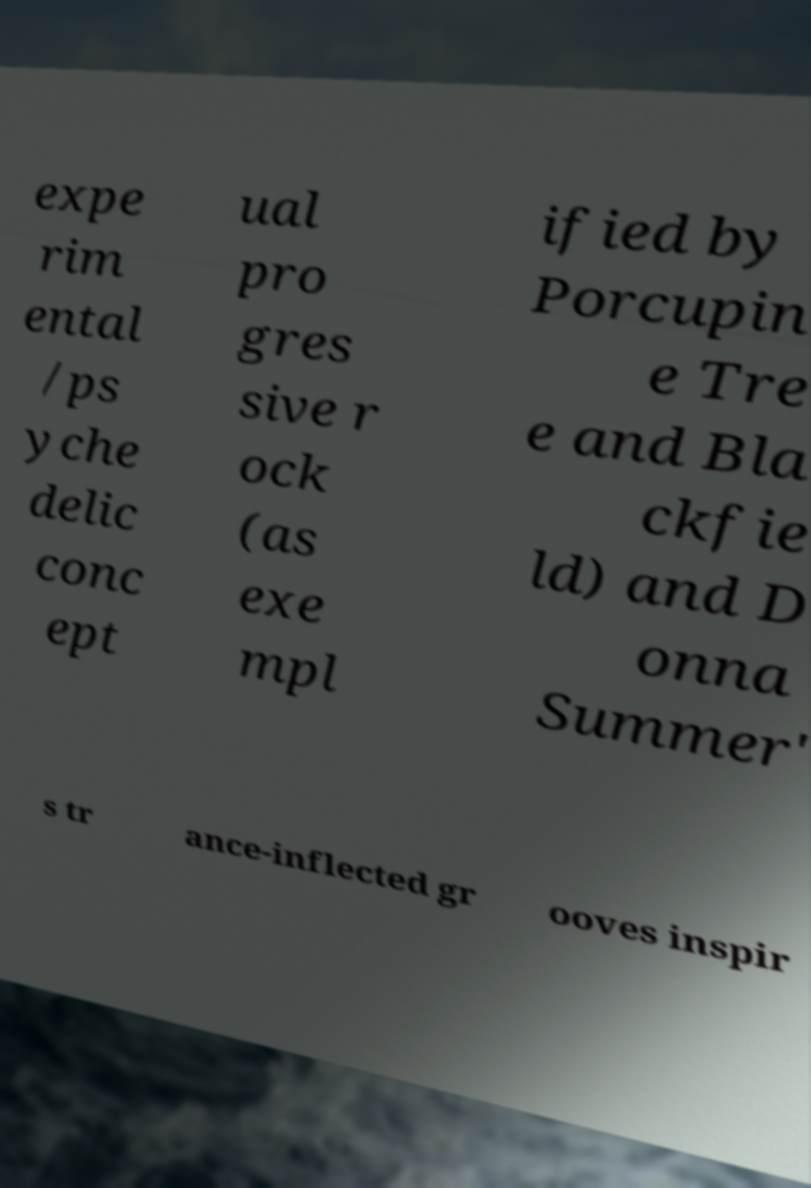Could you assist in decoding the text presented in this image and type it out clearly? expe rim ental /ps yche delic conc ept ual pro gres sive r ock (as exe mpl ified by Porcupin e Tre e and Bla ckfie ld) and D onna Summer' s tr ance-inflected gr ooves inspir 